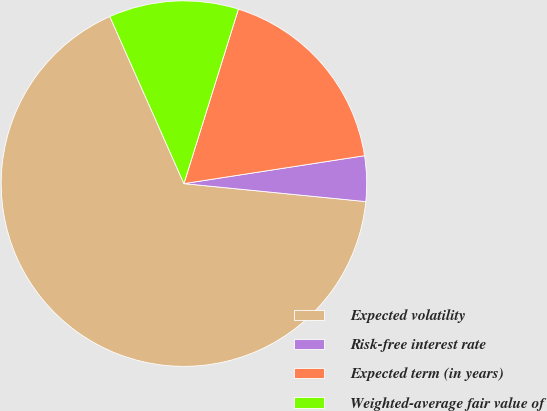<chart> <loc_0><loc_0><loc_500><loc_500><pie_chart><fcel>Expected volatility<fcel>Risk-free interest rate<fcel>Expected term (in years)<fcel>Weighted-average fair value of<nl><fcel>66.78%<fcel>4.01%<fcel>17.74%<fcel>11.46%<nl></chart> 